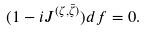Convert formula to latex. <formula><loc_0><loc_0><loc_500><loc_500>( 1 - i J ^ { ( \zeta , \bar { \zeta } ) } ) d f = 0 .</formula> 